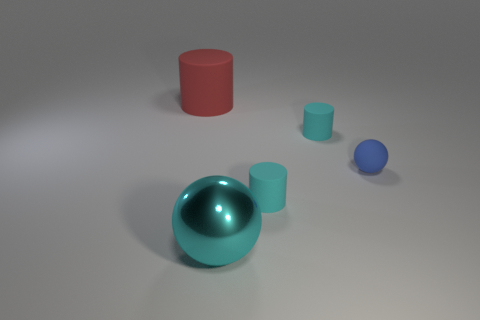Subtract all blue cubes. How many cyan cylinders are left? 2 Subtract all tiny cyan cylinders. How many cylinders are left? 1 Subtract 1 cylinders. How many cylinders are left? 2 Add 3 spheres. How many objects exist? 8 Subtract all blue cylinders. Subtract all blue spheres. How many cylinders are left? 3 Subtract all cylinders. How many objects are left? 2 Subtract all brown rubber things. Subtract all tiny blue matte balls. How many objects are left? 4 Add 4 big red objects. How many big red objects are left? 5 Add 1 big green rubber cylinders. How many big green rubber cylinders exist? 1 Subtract 0 red spheres. How many objects are left? 5 